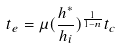<formula> <loc_0><loc_0><loc_500><loc_500>t _ { e } = \mu ( \frac { h ^ { * } } { h _ { i } } ) ^ { \frac { 1 } { 1 - n } } t _ { c }</formula> 